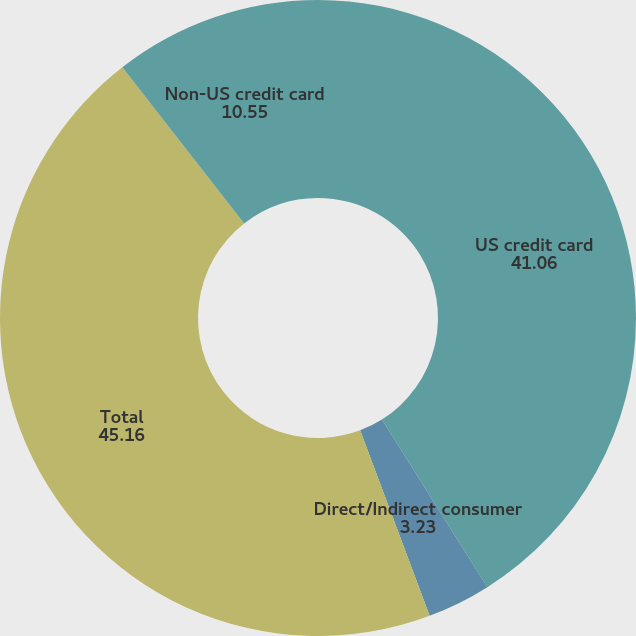Convert chart to OTSL. <chart><loc_0><loc_0><loc_500><loc_500><pie_chart><fcel>US credit card<fcel>Direct/Indirect consumer<fcel>Total<fcel>Non-US credit card<nl><fcel>41.06%<fcel>3.23%<fcel>45.16%<fcel>10.55%<nl></chart> 